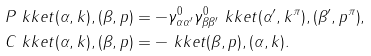<formula> <loc_0><loc_0><loc_500><loc_500>& P \ k k e t { ( \alpha , k ) , ( \beta , p ) } = - \gamma ^ { 0 } _ { \alpha \alpha ^ { \prime } } \gamma ^ { 0 } _ { \beta \beta ^ { \prime } } \ k k e t { ( \alpha ^ { \prime } , k ^ { \pi } ) , ( \beta ^ { \prime } , p ^ { \pi } ) } , \\ & C \ k k e t { ( \alpha , k ) , ( \beta , p ) } = - \ k k e t { ( \beta , p ) , ( \alpha , k ) } .</formula> 